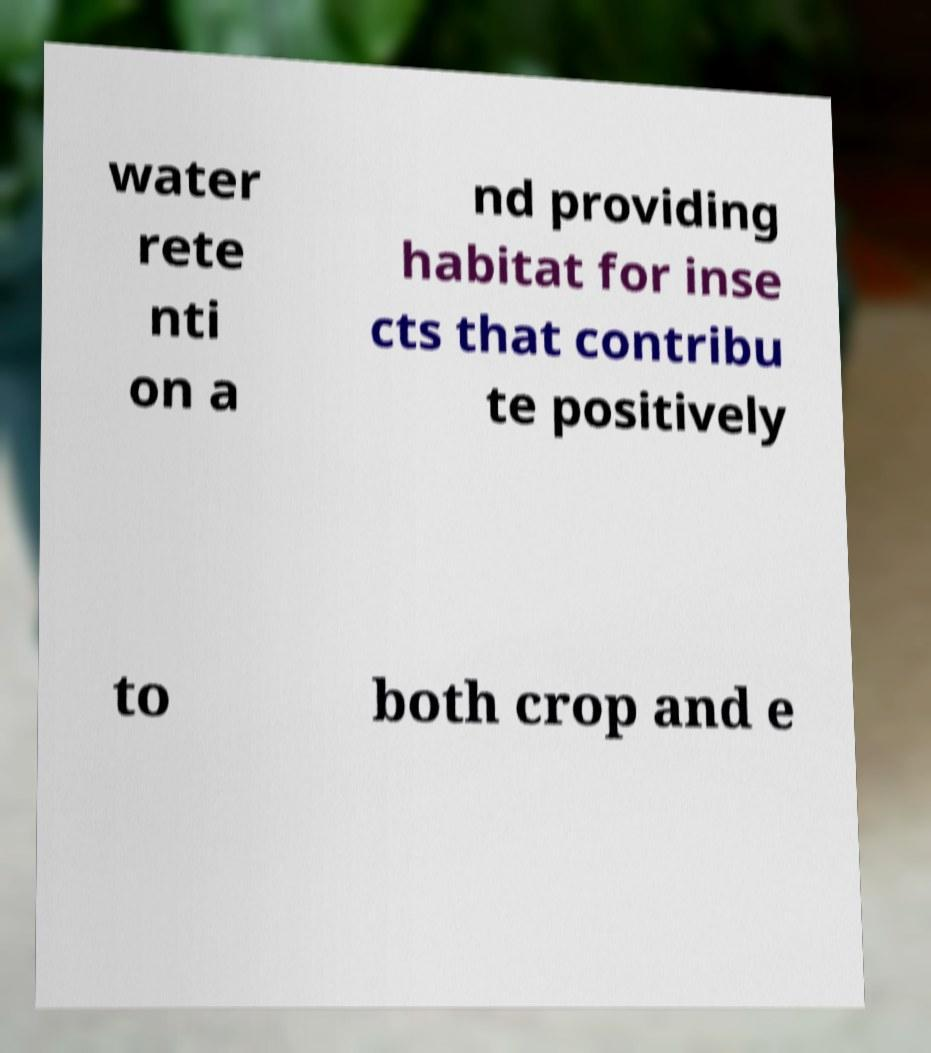Could you extract and type out the text from this image? water rete nti on a nd providing habitat for inse cts that contribu te positively to both crop and e 